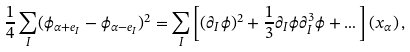Convert formula to latex. <formula><loc_0><loc_0><loc_500><loc_500>\frac { 1 } { 4 } \sum _ { I } ( \phi _ { \alpha + e _ { I } } - \phi _ { \alpha - e _ { I } } ) ^ { 2 } = \sum _ { I } \left [ ( \partial _ { I } \phi ) ^ { 2 } + \frac { 1 } { 3 } \partial _ { I } \phi \partial _ { I } ^ { 3 } \phi + \dots \right ] ( x _ { \alpha } ) \, ,</formula> 